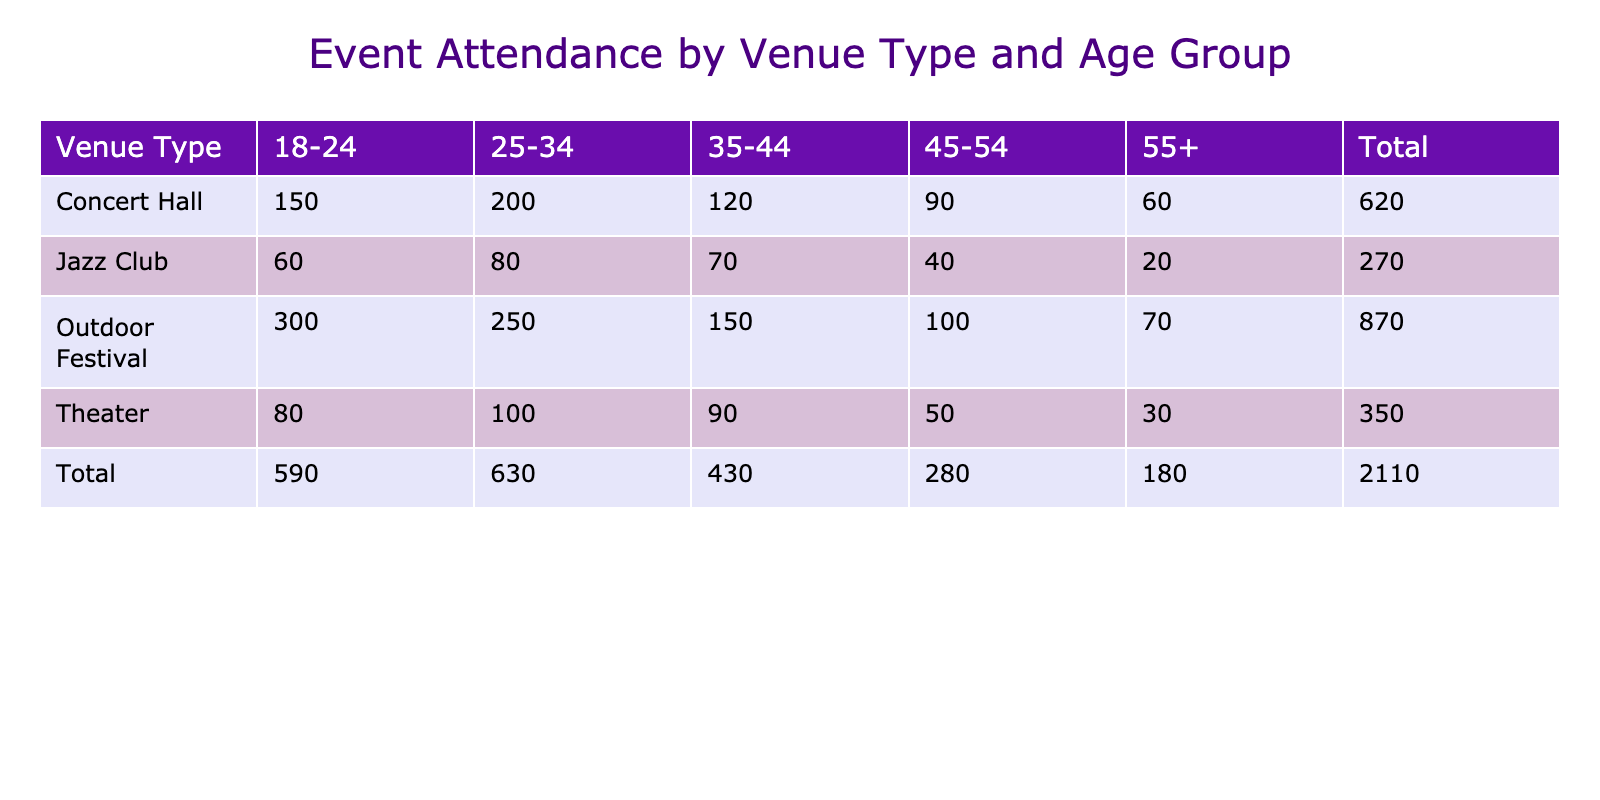What is the total attendance for Concert Halls? To find the total attendance for Concert Halls, we sum the attendance across all age groups listed under Concert Hall: 150 + 200 + 120 + 90 + 60 = 620.
Answer: 620 Which age group has the highest attendance in Outdoor Festivals? Looking at the attendance numbers for each age group in Outdoor Festivals, the age group 18-24 has the highest attendance of 300.
Answer: 18-24 Is the attendance for the Jazz Club higher for age group 25-34 compared to age group 35-44? For Jazz Club, the attendance for age group 25-34 is 80, while for 35-44 it is 70. Since 80 is greater than 70, it is true that the attendance for 25-34 is higher.
Answer: Yes What is the difference in attendance between the Theater for age groups 18-24 and 45-54? The attendance for Theater in age group 18-24 is 80, and for 45-54 it is 50. To find the difference, we subtract the latter from the former: 80 - 50 = 30.
Answer: 30 What is the average attendance across all age groups for the Outdoor Festival? The total attendance for Outdoor Festival is 300 + 250 + 150 + 100 + 70 = 870. There are 5 age groups, so dividing 870 by 5 gives us an average of 174.
Answer: 174 Are there more attendees in the 55+ age group at Concert Halls than at Theaters? The attendance for 55+ at Concert Halls is 60, and at Theaters, it is 30. Since 60 is greater than 30, this statement is true.
Answer: Yes What is the total attendance for all venues combined for the age group 35-44? We sum the attendance for 35-44 across all venues: Concert Hall (120) + Outdoor Festival (150) + Theater (90) + Jazz Club (70) = 430.
Answer: 430 Which venue type has the lowest attendance in the 45-54 age group? In the 45-54 age group, Concert Hall has 90, Outdoor Festival has 100, Theater has 50, and Jazz Club has 40. The lowest attendance is at the Jazz Club with 40.
Answer: Jazz Club What is the total attendance for the 18-24 age group across all venues? To get the total attendance for 18-24, we sum: Concert Hall (150) + Outdoor Festival (300) + Theater (80) + Jazz Club (60) = 590.
Answer: 590 